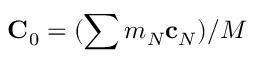<formula> <loc_0><loc_0><loc_500><loc_500>{ C } _ { 0 } = ( \sum m _ { N } { c } _ { N } ) / M</formula> 